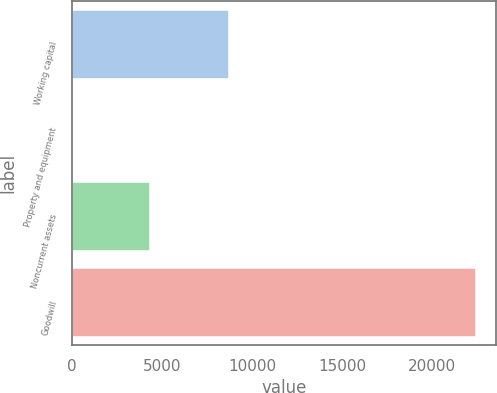Convert chart to OTSL. <chart><loc_0><loc_0><loc_500><loc_500><bar_chart><fcel>Working capital<fcel>Property and equipment<fcel>Noncurrent assets<fcel>Goodwill<nl><fcel>8749<fcel>71<fcel>4334<fcel>22429<nl></chart> 